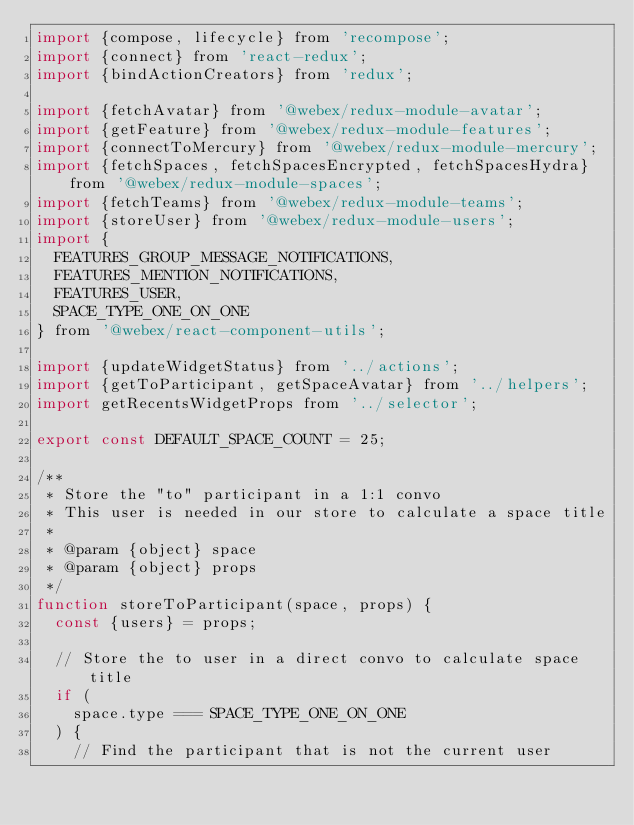Convert code to text. <code><loc_0><loc_0><loc_500><loc_500><_JavaScript_>import {compose, lifecycle} from 'recompose';
import {connect} from 'react-redux';
import {bindActionCreators} from 'redux';

import {fetchAvatar} from '@webex/redux-module-avatar';
import {getFeature} from '@webex/redux-module-features';
import {connectToMercury} from '@webex/redux-module-mercury';
import {fetchSpaces, fetchSpacesEncrypted, fetchSpacesHydra} from '@webex/redux-module-spaces';
import {fetchTeams} from '@webex/redux-module-teams';
import {storeUser} from '@webex/redux-module-users';
import {
  FEATURES_GROUP_MESSAGE_NOTIFICATIONS,
  FEATURES_MENTION_NOTIFICATIONS,
  FEATURES_USER,
  SPACE_TYPE_ONE_ON_ONE
} from '@webex/react-component-utils';

import {updateWidgetStatus} from '../actions';
import {getToParticipant, getSpaceAvatar} from '../helpers';
import getRecentsWidgetProps from '../selector';

export const DEFAULT_SPACE_COUNT = 25;

/**
 * Store the "to" participant in a 1:1 convo
 * This user is needed in our store to calculate a space title
 *
 * @param {object} space
 * @param {object} props
 */
function storeToParticipant(space, props) {
  const {users} = props;

  // Store the to user in a direct convo to calculate space title
  if (
    space.type === SPACE_TYPE_ONE_ON_ONE
  ) {
    // Find the participant that is not the current user</code> 